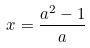Convert formula to latex. <formula><loc_0><loc_0><loc_500><loc_500>x = \frac { a ^ { 2 } - 1 } { a }</formula> 